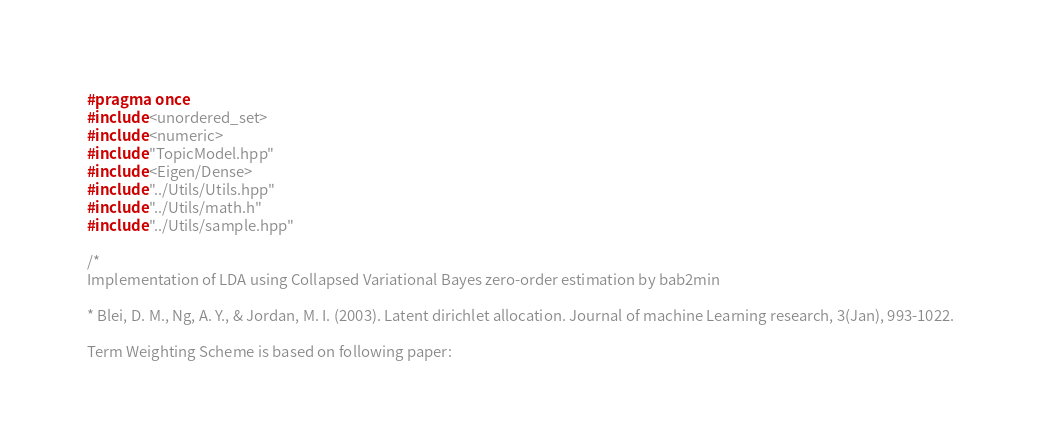Convert code to text. <code><loc_0><loc_0><loc_500><loc_500><_C++_>#pragma once
#include <unordered_set>
#include <numeric>
#include "TopicModel.hpp"
#include <Eigen/Dense>
#include "../Utils/Utils.hpp"
#include "../Utils/math.h"
#include "../Utils/sample.hpp"

/*
Implementation of LDA using Collapsed Variational Bayes zero-order estimation by bab2min

* Blei, D. M., Ng, A. Y., & Jordan, M. I. (2003). Latent dirichlet allocation. Journal of machine Learning research, 3(Jan), 993-1022.

Term Weighting Scheme is based on following paper:</code> 